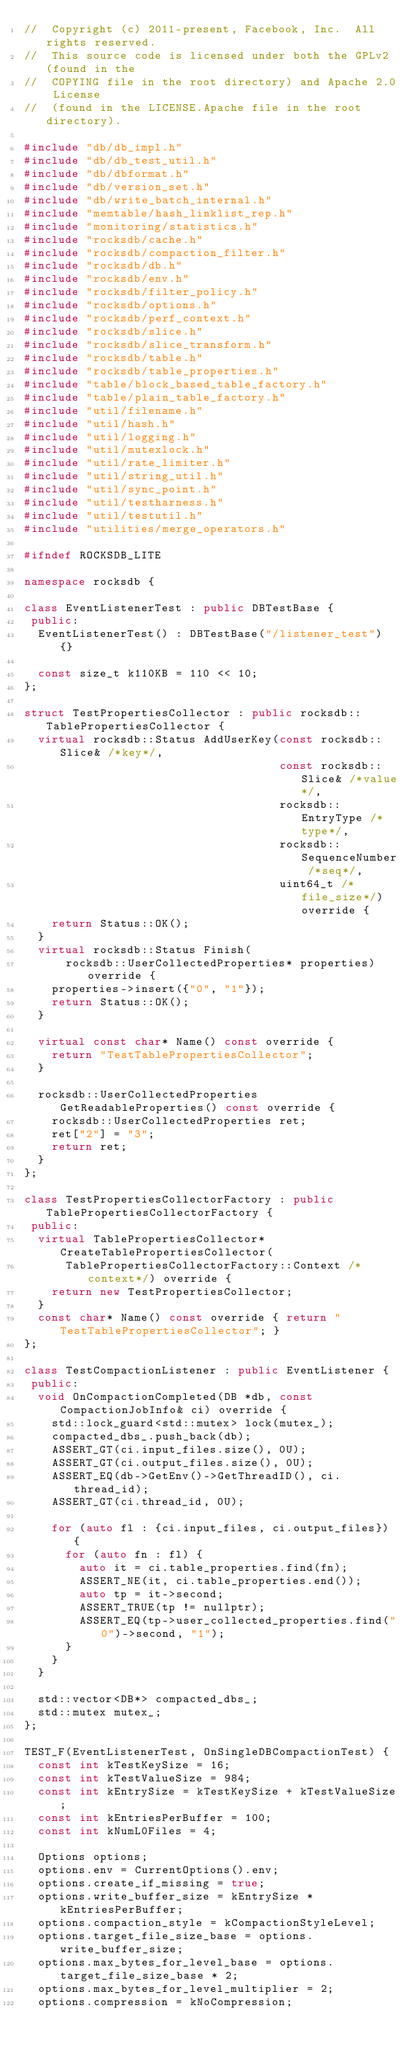Convert code to text. <code><loc_0><loc_0><loc_500><loc_500><_C++_>//  Copyright (c) 2011-present, Facebook, Inc.  All rights reserved.
//  This source code is licensed under both the GPLv2 (found in the
//  COPYING file in the root directory) and Apache 2.0 License
//  (found in the LICENSE.Apache file in the root directory).

#include "db/db_impl.h"
#include "db/db_test_util.h"
#include "db/dbformat.h"
#include "db/version_set.h"
#include "db/write_batch_internal.h"
#include "memtable/hash_linklist_rep.h"
#include "monitoring/statistics.h"
#include "rocksdb/cache.h"
#include "rocksdb/compaction_filter.h"
#include "rocksdb/db.h"
#include "rocksdb/env.h"
#include "rocksdb/filter_policy.h"
#include "rocksdb/options.h"
#include "rocksdb/perf_context.h"
#include "rocksdb/slice.h"
#include "rocksdb/slice_transform.h"
#include "rocksdb/table.h"
#include "rocksdb/table_properties.h"
#include "table/block_based_table_factory.h"
#include "table/plain_table_factory.h"
#include "util/filename.h"
#include "util/hash.h"
#include "util/logging.h"
#include "util/mutexlock.h"
#include "util/rate_limiter.h"
#include "util/string_util.h"
#include "util/sync_point.h"
#include "util/testharness.h"
#include "util/testutil.h"
#include "utilities/merge_operators.h"

#ifndef ROCKSDB_LITE

namespace rocksdb {

class EventListenerTest : public DBTestBase {
 public:
  EventListenerTest() : DBTestBase("/listener_test") {}

  const size_t k110KB = 110 << 10;
};

struct TestPropertiesCollector : public rocksdb::TablePropertiesCollector {
  virtual rocksdb::Status AddUserKey(const rocksdb::Slice& /*key*/,
                                     const rocksdb::Slice& /*value*/,
                                     rocksdb::EntryType /*type*/,
                                     rocksdb::SequenceNumber /*seq*/,
                                     uint64_t /*file_size*/) override {
    return Status::OK();
  }
  virtual rocksdb::Status Finish(
      rocksdb::UserCollectedProperties* properties) override {
    properties->insert({"0", "1"});
    return Status::OK();
  }

  virtual const char* Name() const override {
    return "TestTablePropertiesCollector";
  }

  rocksdb::UserCollectedProperties GetReadableProperties() const override {
    rocksdb::UserCollectedProperties ret;
    ret["2"] = "3";
    return ret;
  }
};

class TestPropertiesCollectorFactory : public TablePropertiesCollectorFactory {
 public:
  virtual TablePropertiesCollector* CreateTablePropertiesCollector(
      TablePropertiesCollectorFactory::Context /*context*/) override {
    return new TestPropertiesCollector;
  }
  const char* Name() const override { return "TestTablePropertiesCollector"; }
};

class TestCompactionListener : public EventListener {
 public:
  void OnCompactionCompleted(DB *db, const CompactionJobInfo& ci) override {
    std::lock_guard<std::mutex> lock(mutex_);
    compacted_dbs_.push_back(db);
    ASSERT_GT(ci.input_files.size(), 0U);
    ASSERT_GT(ci.output_files.size(), 0U);
    ASSERT_EQ(db->GetEnv()->GetThreadID(), ci.thread_id);
    ASSERT_GT(ci.thread_id, 0U);

    for (auto fl : {ci.input_files, ci.output_files}) {
      for (auto fn : fl) {
        auto it = ci.table_properties.find(fn);
        ASSERT_NE(it, ci.table_properties.end());
        auto tp = it->second;
        ASSERT_TRUE(tp != nullptr);
        ASSERT_EQ(tp->user_collected_properties.find("0")->second, "1");
      }
    }
  }

  std::vector<DB*> compacted_dbs_;
  std::mutex mutex_;
};

TEST_F(EventListenerTest, OnSingleDBCompactionTest) {
  const int kTestKeySize = 16;
  const int kTestValueSize = 984;
  const int kEntrySize = kTestKeySize + kTestValueSize;
  const int kEntriesPerBuffer = 100;
  const int kNumL0Files = 4;

  Options options;
  options.env = CurrentOptions().env;
  options.create_if_missing = true;
  options.write_buffer_size = kEntrySize * kEntriesPerBuffer;
  options.compaction_style = kCompactionStyleLevel;
  options.target_file_size_base = options.write_buffer_size;
  options.max_bytes_for_level_base = options.target_file_size_base * 2;
  options.max_bytes_for_level_multiplier = 2;
  options.compression = kNoCompression;</code> 